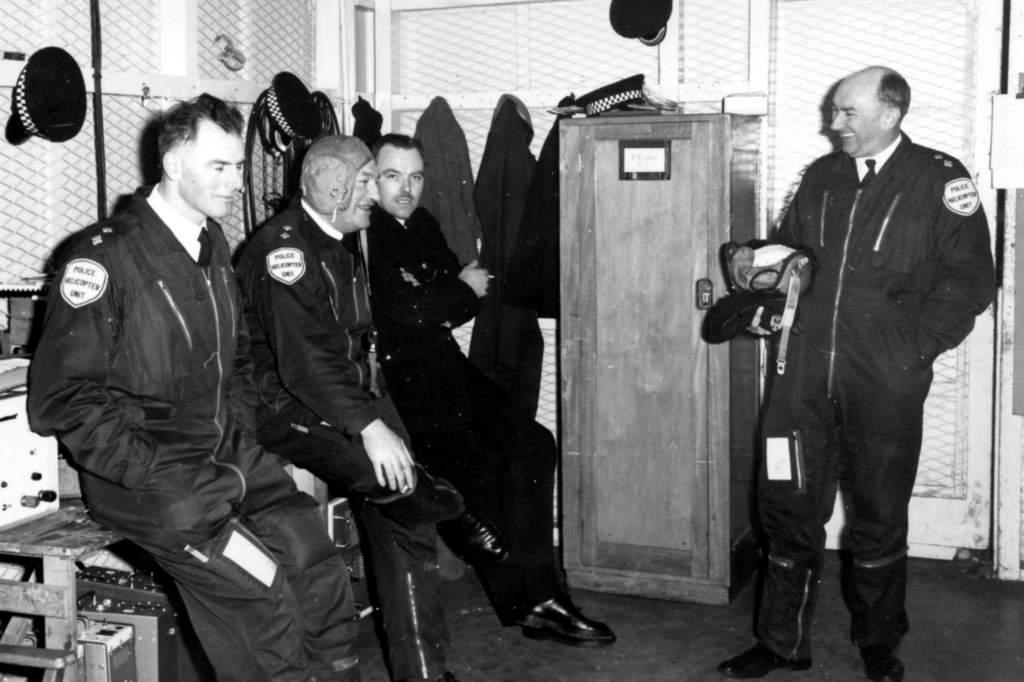What are the people in the image doing? The people in the image are sitting. Can you describe the man on the right side of the image? There is a man standing on the right side of the image. What type of object can be seen in the image? There is a wooden object in the image. What is the purpose of the structure visible in the image? There is a fence in the image, which is likely used to enclose or separate areas. Are there any giraffes visible at the zoo in the image? There is no mention of a zoo or any giraffes in the image. The image features people sitting, a man standing, a wooden object, and a fence. 